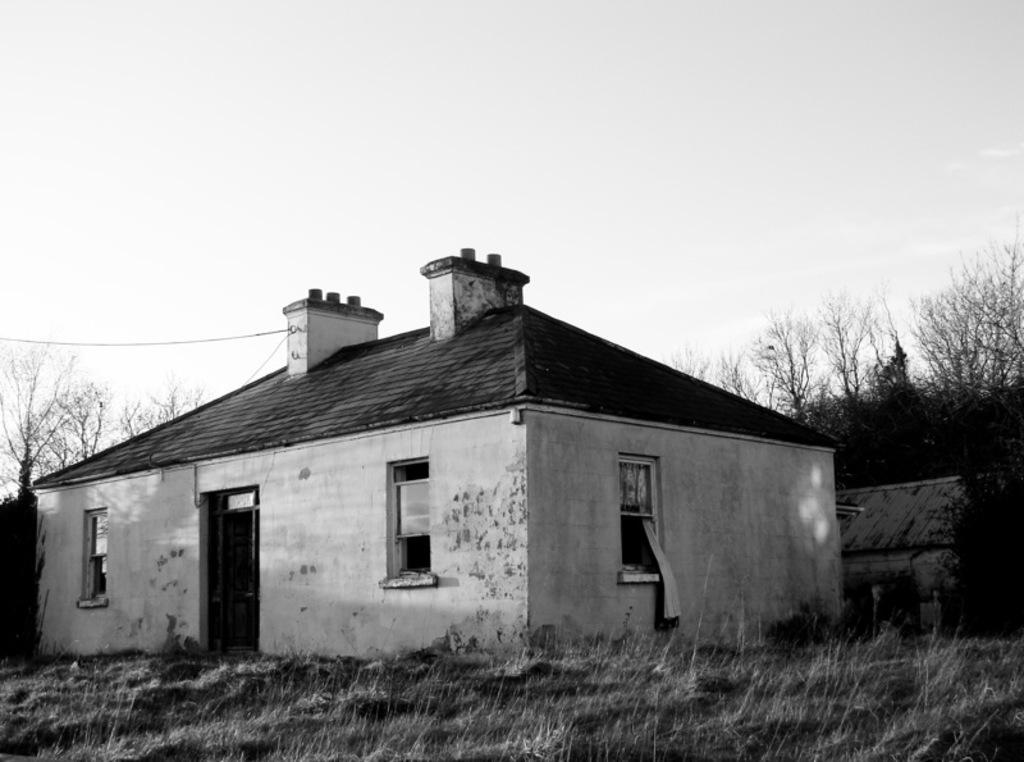What type of structures are present in the image? There are sheds in the image. What type of vegetation can be seen in the image? There are trees in the image. What is the ground surface like in the image? There is grass at the bottom of the image. What is visible in the background of the image? The sky is visible in the background of the image. What type of object can be seen in the image that is not a structure or vegetation? There is a wire in the image. How many times do the people in the image express their love for each other? There are no people present in the image, so it is not possible to determine if they express love for each other. Can you tell me where the cellar is located in the image? There is no cellar present in the image. 